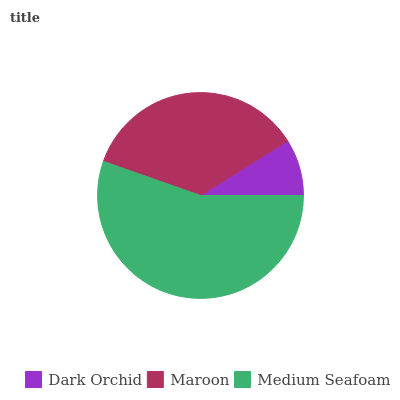Is Dark Orchid the minimum?
Answer yes or no. Yes. Is Medium Seafoam the maximum?
Answer yes or no. Yes. Is Maroon the minimum?
Answer yes or no. No. Is Maroon the maximum?
Answer yes or no. No. Is Maroon greater than Dark Orchid?
Answer yes or no. Yes. Is Dark Orchid less than Maroon?
Answer yes or no. Yes. Is Dark Orchid greater than Maroon?
Answer yes or no. No. Is Maroon less than Dark Orchid?
Answer yes or no. No. Is Maroon the high median?
Answer yes or no. Yes. Is Maroon the low median?
Answer yes or no. Yes. Is Dark Orchid the high median?
Answer yes or no. No. Is Dark Orchid the low median?
Answer yes or no. No. 